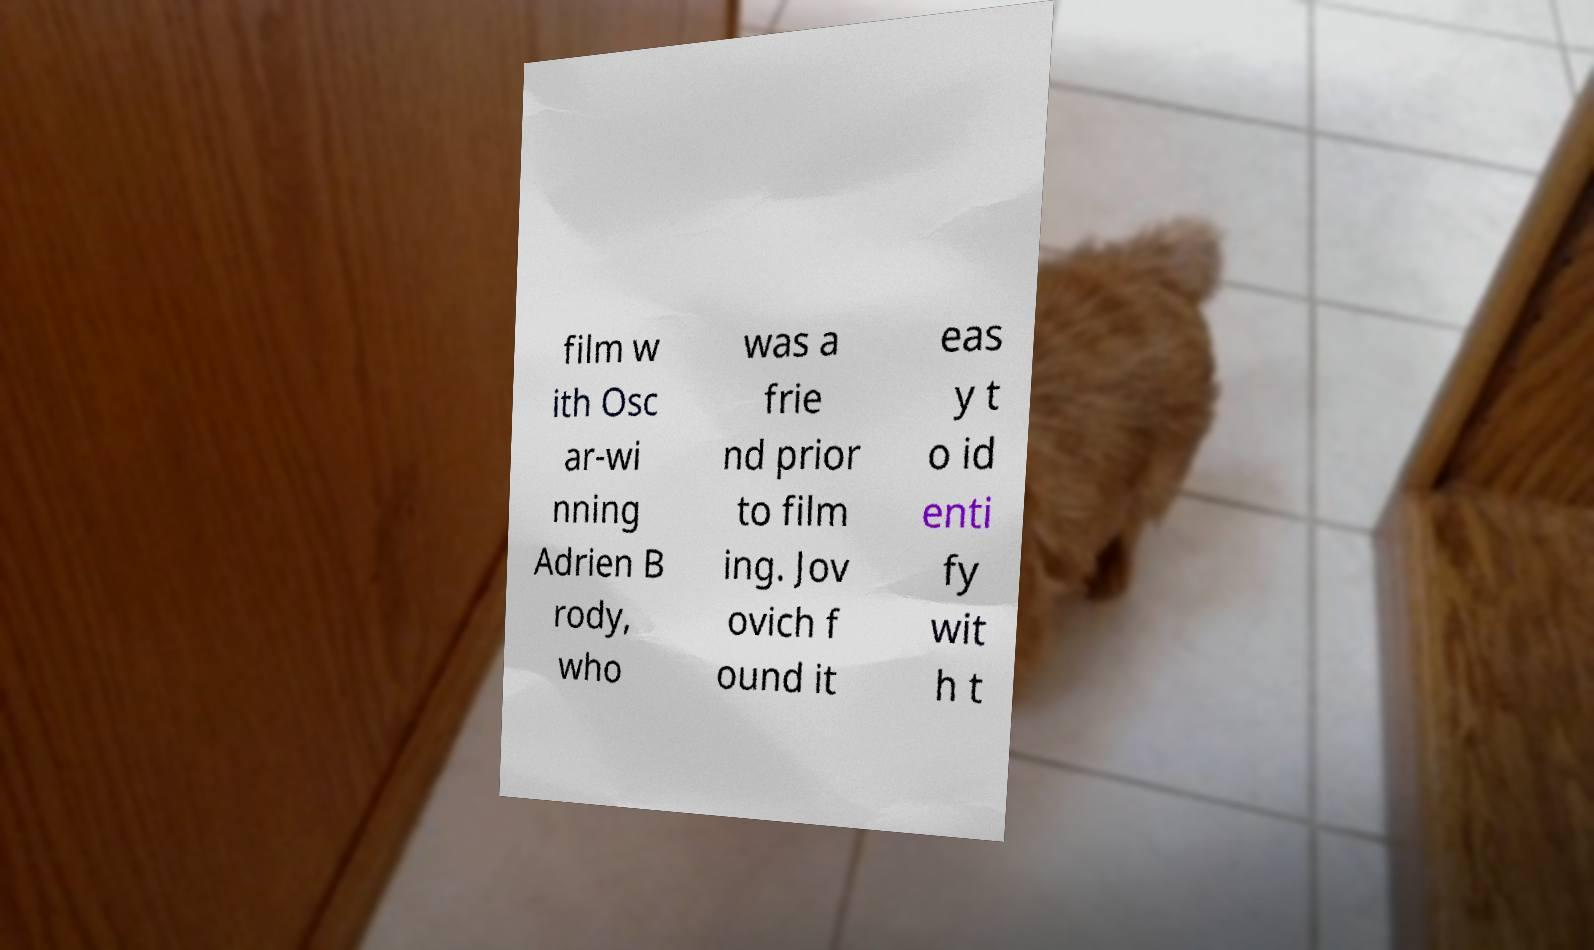Please identify and transcribe the text found in this image. film w ith Osc ar-wi nning Adrien B rody, who was a frie nd prior to film ing. Jov ovich f ound it eas y t o id enti fy wit h t 